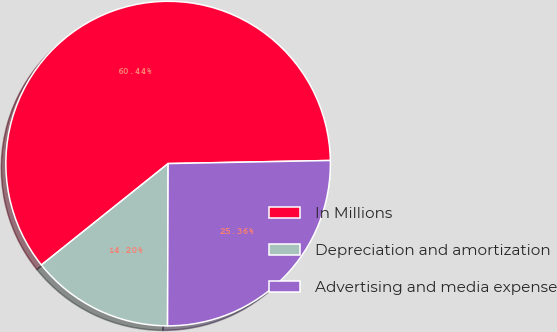<chart> <loc_0><loc_0><loc_500><loc_500><pie_chart><fcel>In Millions<fcel>Depreciation and amortization<fcel>Advertising and media expense<nl><fcel>60.44%<fcel>14.2%<fcel>25.36%<nl></chart> 